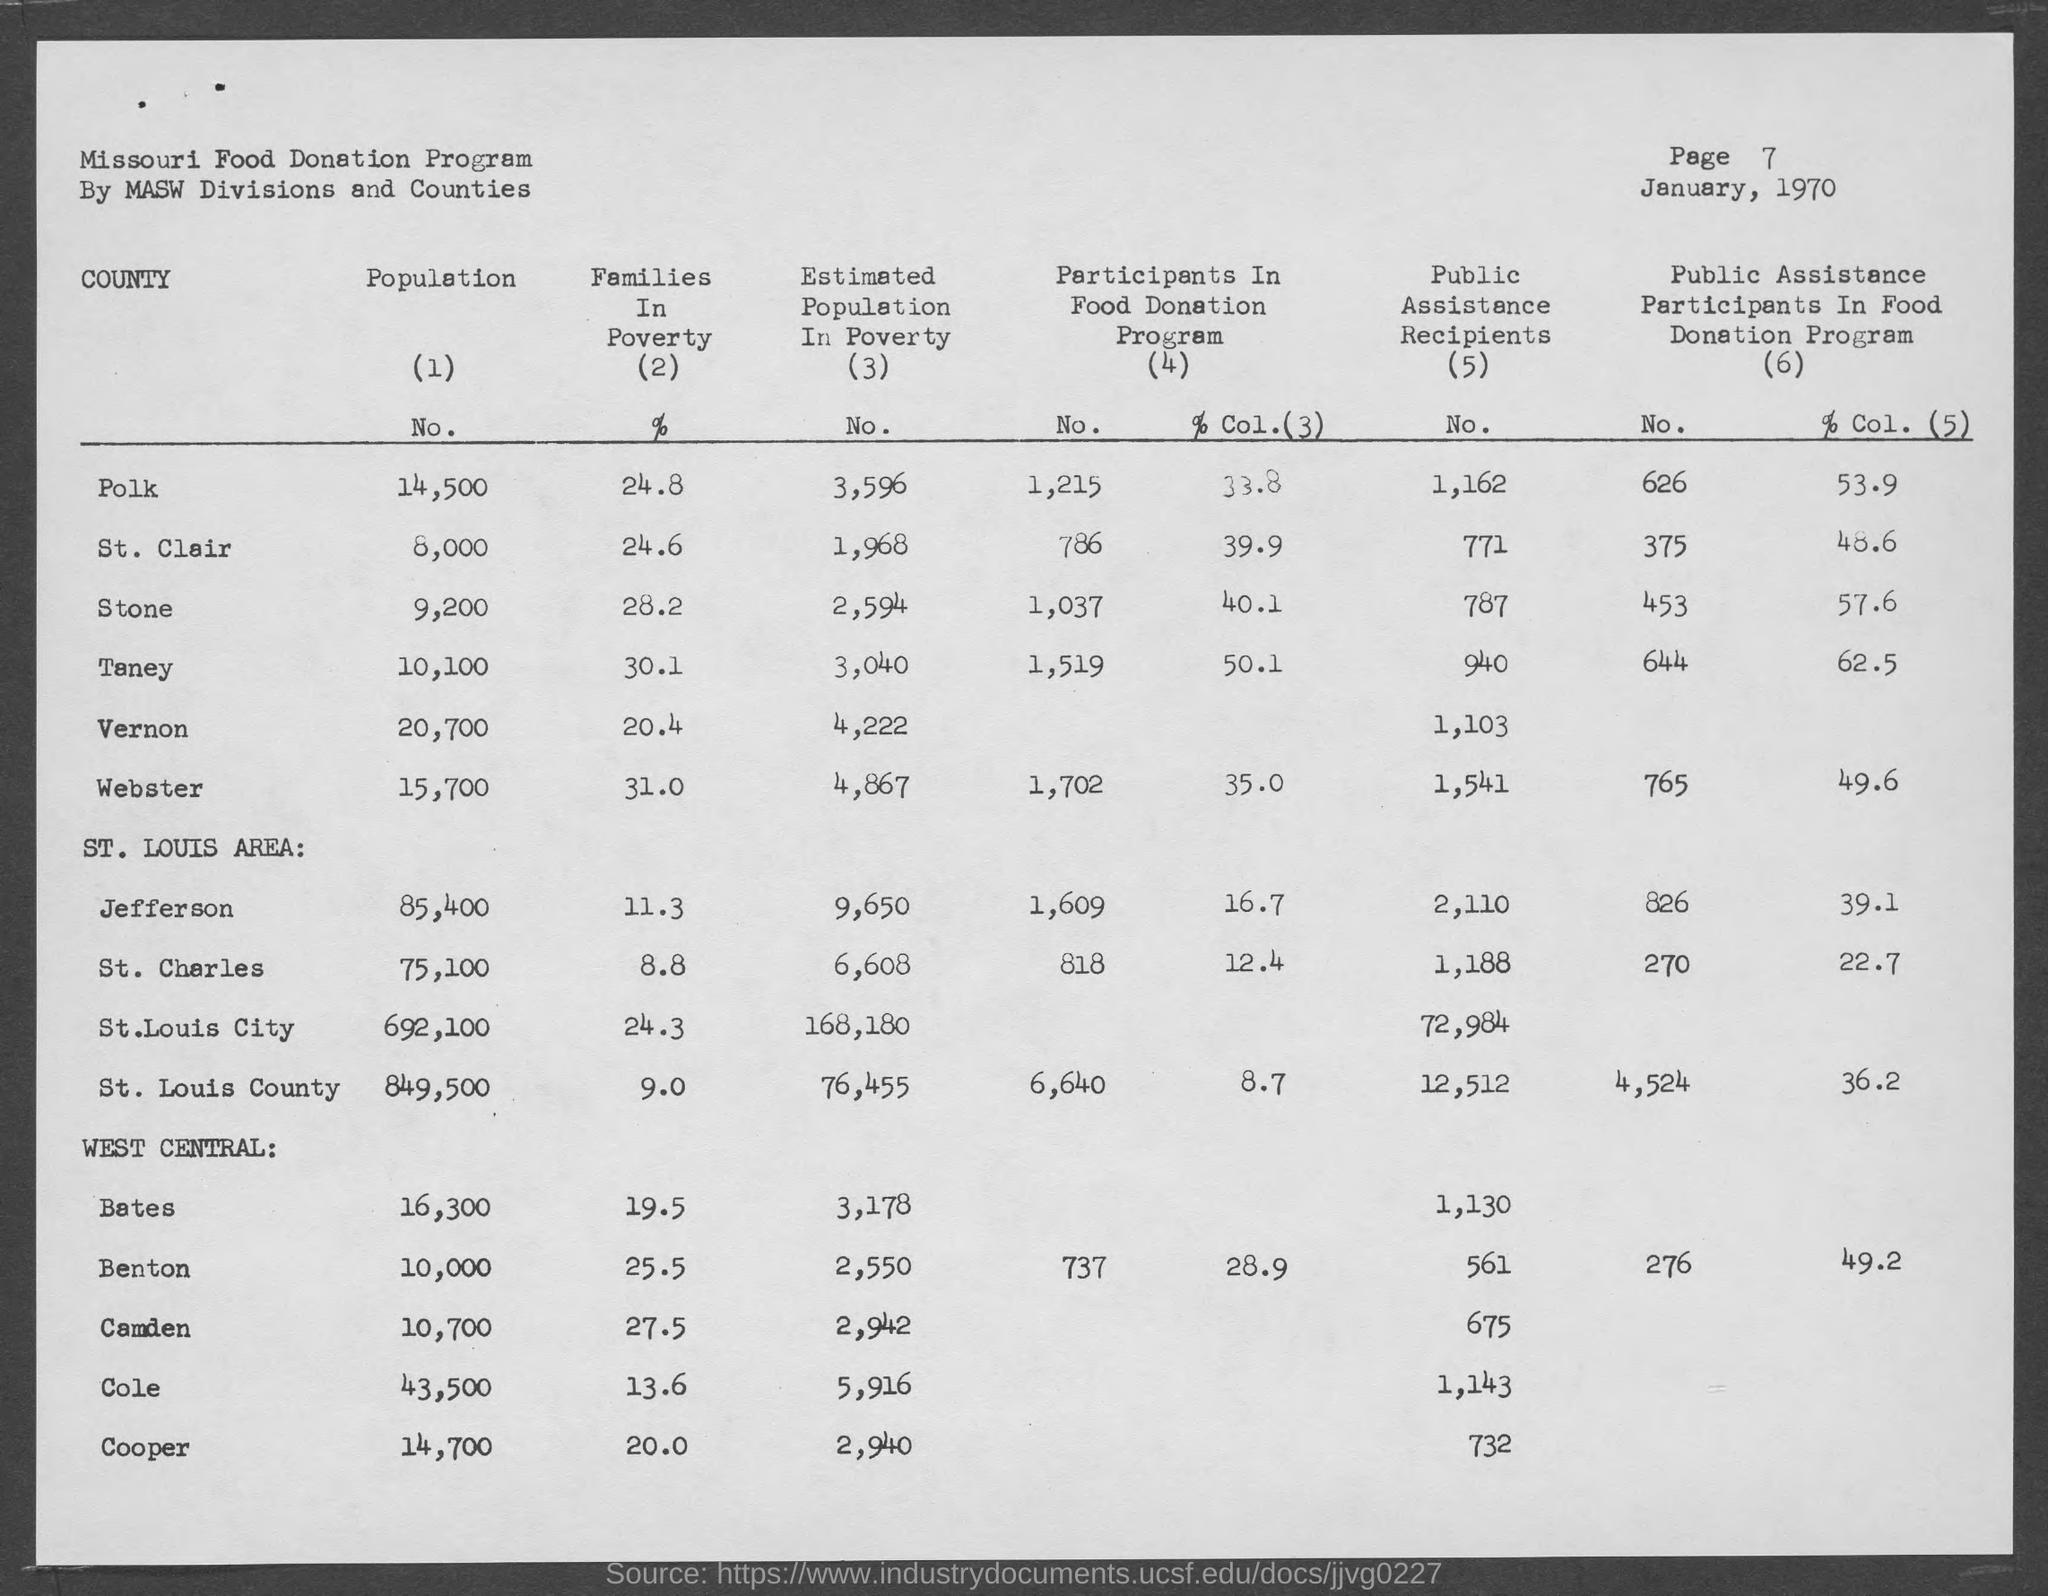Specify some key components in this picture. The population in St. Clair county is 8,000. The population in Benton county is currently 10,000. According to data from Vernon County, the population is approximately 20,700. The population in Polk County is approximately 14,500," declares a confident and knowledgeable speaker. In Cole county, the population is 43,500. 